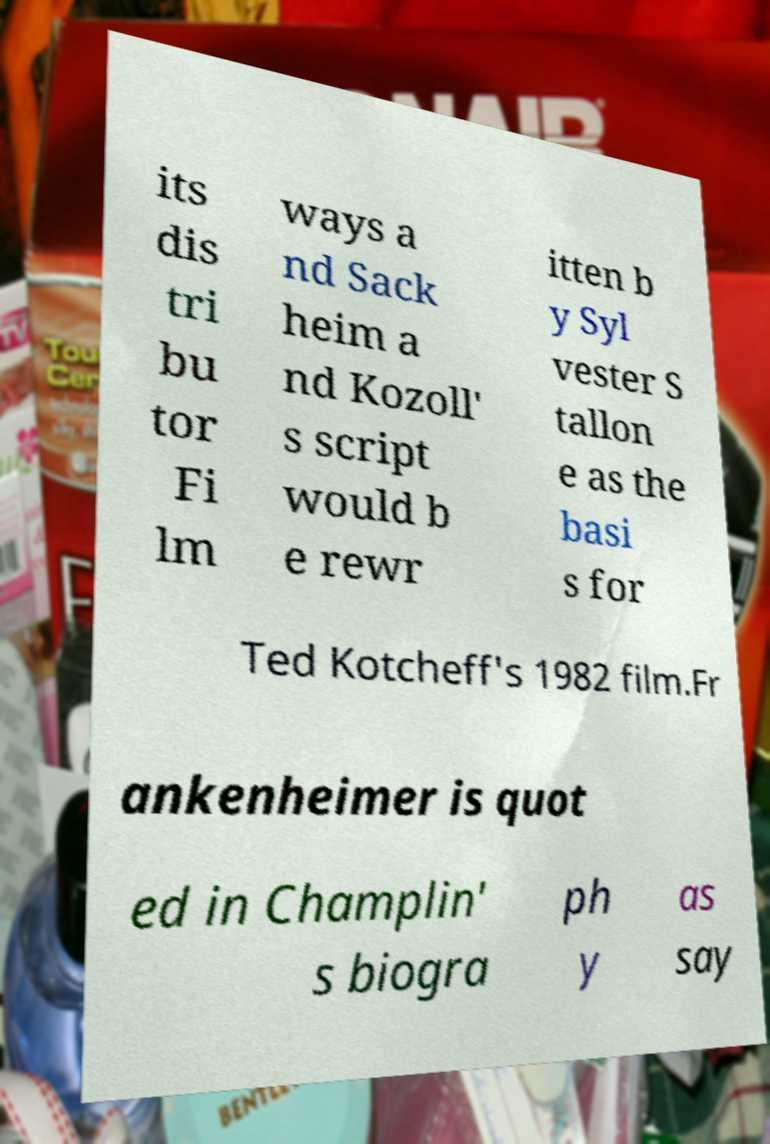I need the written content from this picture converted into text. Can you do that? its dis tri bu tor Fi lm ways a nd Sack heim a nd Kozoll' s script would b e rewr itten b y Syl vester S tallon e as the basi s for Ted Kotcheff's 1982 film.Fr ankenheimer is quot ed in Champlin' s biogra ph y as say 